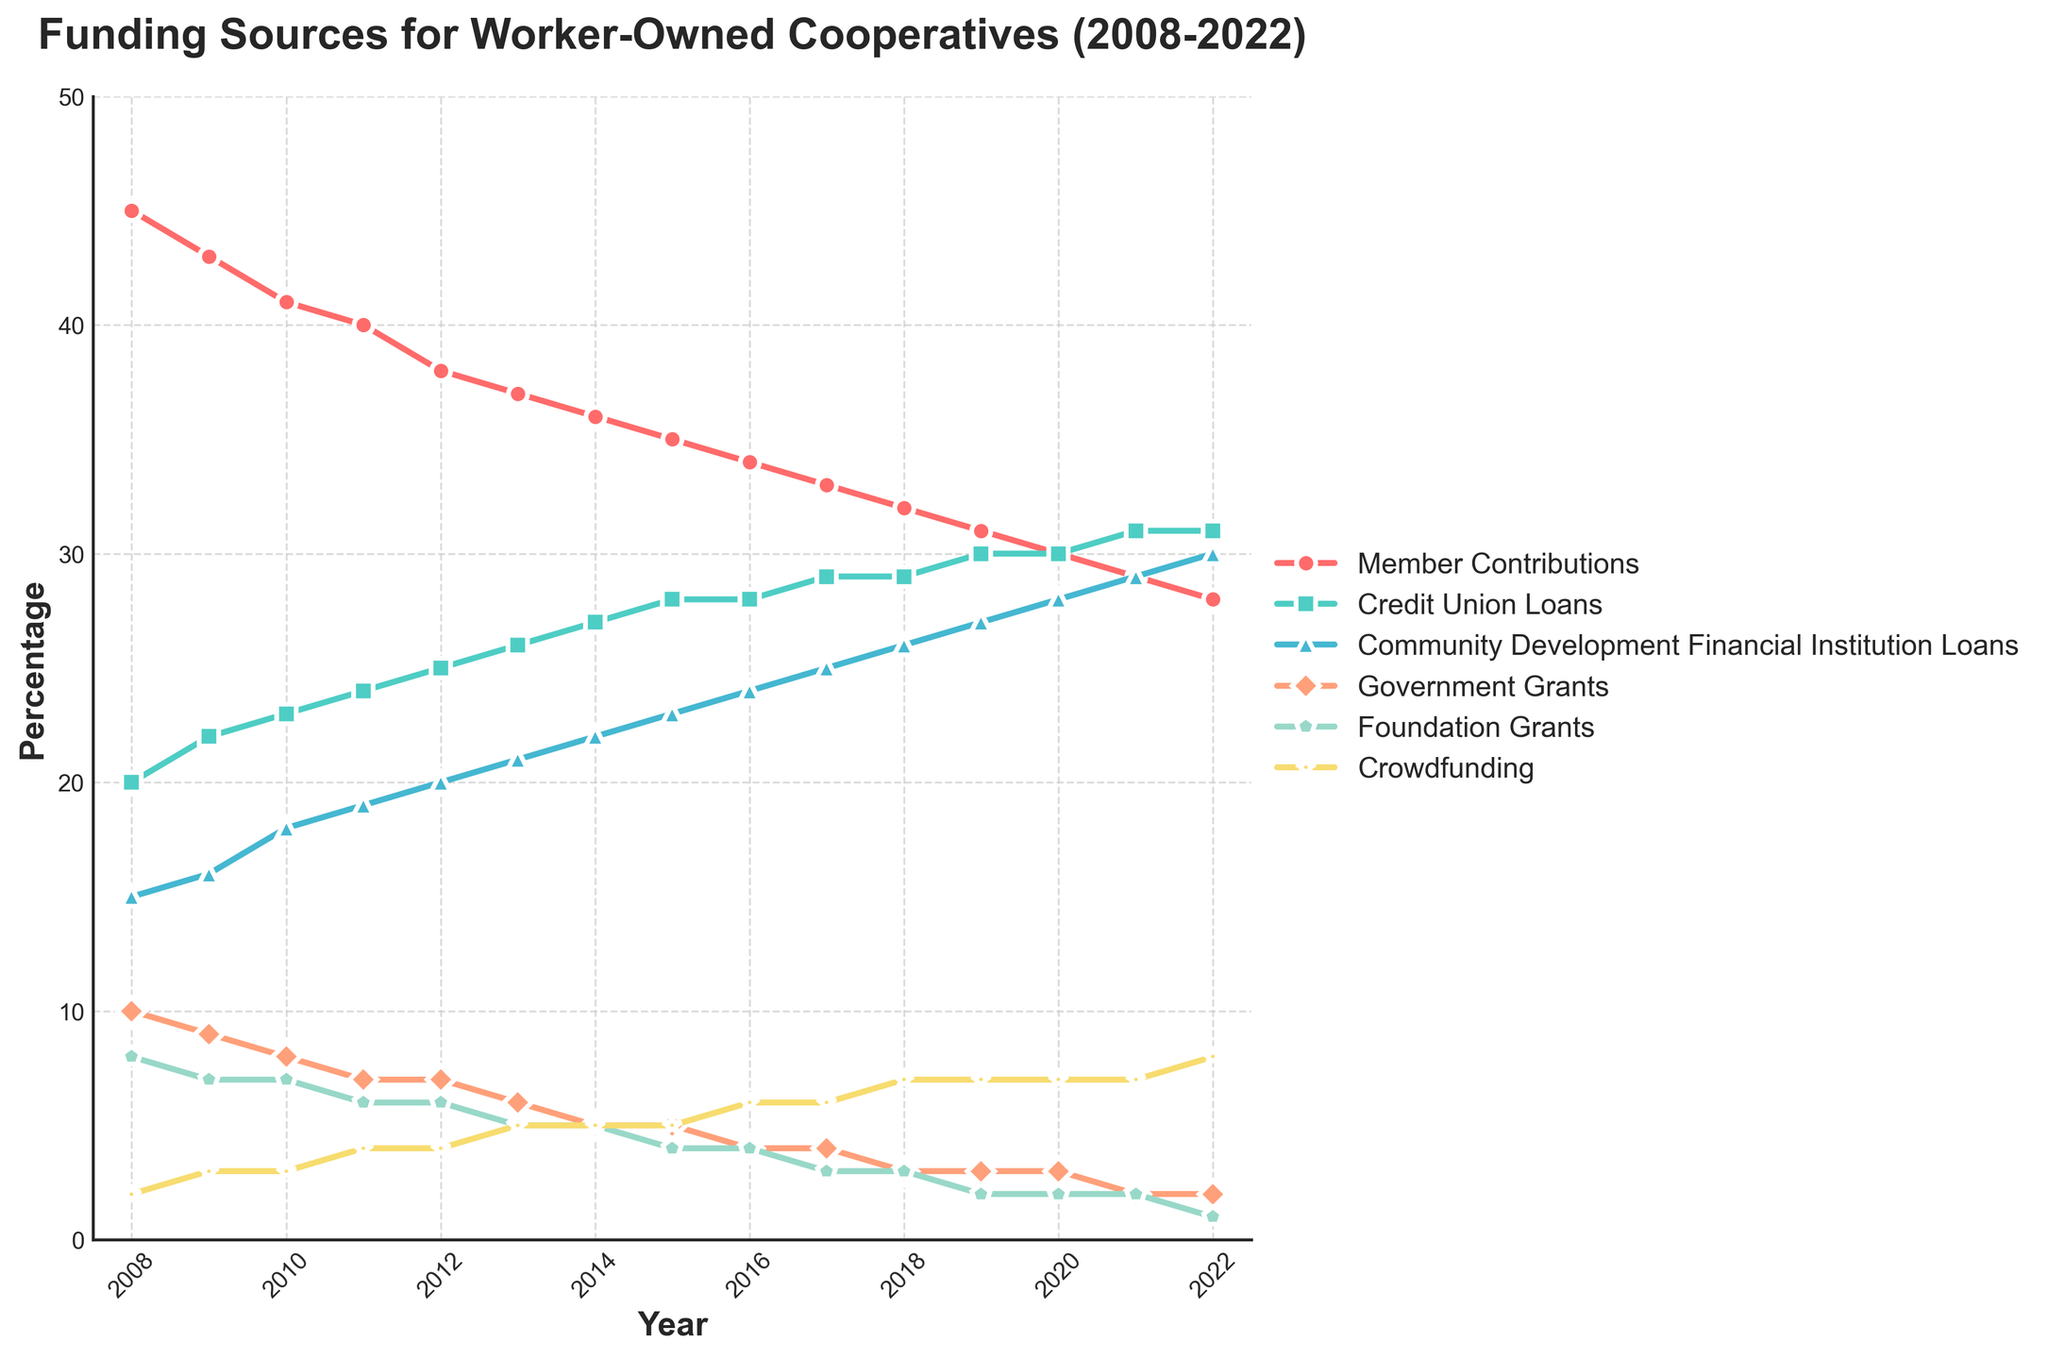What's the trend in Member Contributions over the years? By looking at the plot for Member Contributions (represented with red lines and circle markers), we can see that the percentage decreases steadily from 45% in 2008 to 28% in 2022.
Answer: Decreasing trend How do Foundation Grants change from 2008 to 2022? Foundation Grants are represented by blue triangle markers. They start at 8% in 2008 and gradually decline to 1% in 2022.
Answer: Decreasing trend Compare the relative change in Community Development Financial Institution Loans and Government Grants from 2008 to 2022. Community Development Financial Institution Loans (green diamonds) increase from 15% in 2008 to 30% in 2022. In contrast, Government Grants (peach rhombuses) decrease from 10% in 2008 to 2% in 2022.
Answer: CDFI Loans increase, Government Grants decrease Which funding source has the most significant increase percentage-wise from 2008 to 2022? Crowdfunding (yellow stars) grows from 2% in 2008 to 8% in 2022. This is the most considerable percentage increase relative to its initial value compared to other sources.
Answer: Crowdfunding What are the two largest funding sources in 2022, and how do their percentages compare? In 2022, the two largest funding sources are Community Development Financial Institution Loans (30%) and Credit Union Loans (31%). The difference between them is 1%.
Answer: Credit Union Loans (31%) and CDFI Loans (30%), difference: 1% What is the combined percentage of Member Contributions and Government Grants in 2010? In 2010, Member Contributions are 41%, and Government Grants are 8%. Adding them together: 41% + 8% = 49%.
Answer: 49% How does the percentage of Credit Union Loans compare to Member Contributions in 2015? In 2015, Member Contributions are 35%, whereas Credit Union Loans are 28%. So, Member Contributions are higher by 7%.
Answer: Member Contributions are higher by 7% Which funding source remains at a relatively constant level throughout the years, and what is the range? Crowdfunding remains relatively constant, starting from 2% and increasing slightly to 8%. This is a smaller range compared to variations seen in other funding sources.
Answer: Crowdfunding, range: 2% to 8% In which year do Community Development Financial Institution Loans surpass Credit Union Loans in percentage? In 2022, Community Development Financial Institution Loans are 30%, which equals Credit Union Loans (31%). However, the major surpass happened before that threshold was reached.
Answer: 2022 What notable shift is visible in the percentage of Foundation Grants from 2017 to 2022? Foundation Grants drop from 3% in 2017 to 1% in 2022. This sharp decline reflects a significant reduction in contributions over these years.
Answer: Decrease from 3% to 1% 